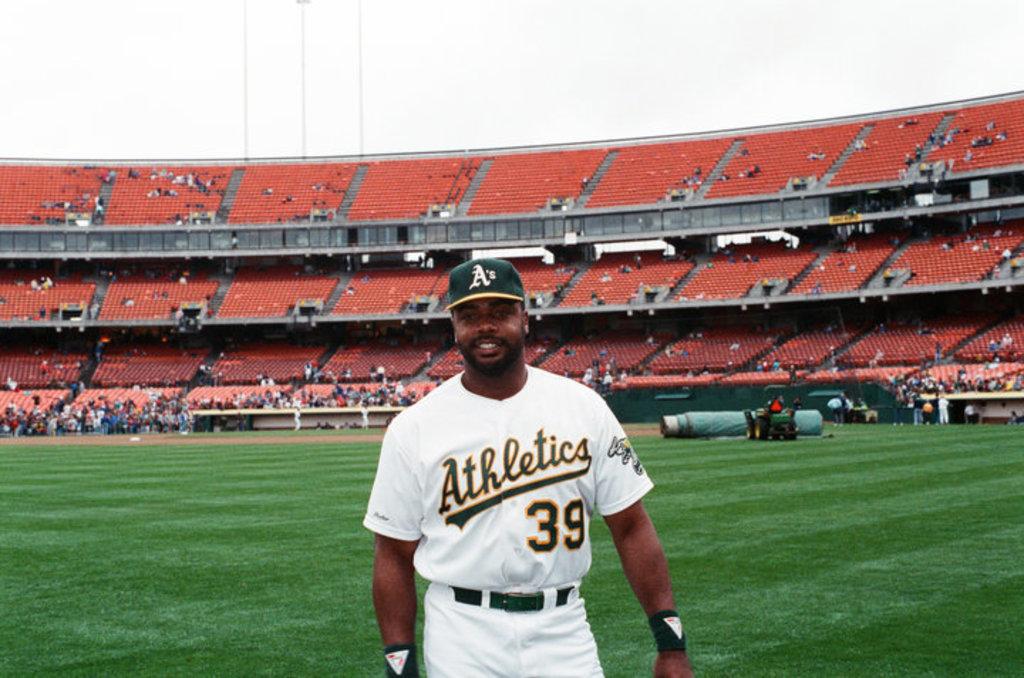What team does he play for?
Provide a short and direct response. Athletics. What is his number?
Give a very brief answer. 39. 